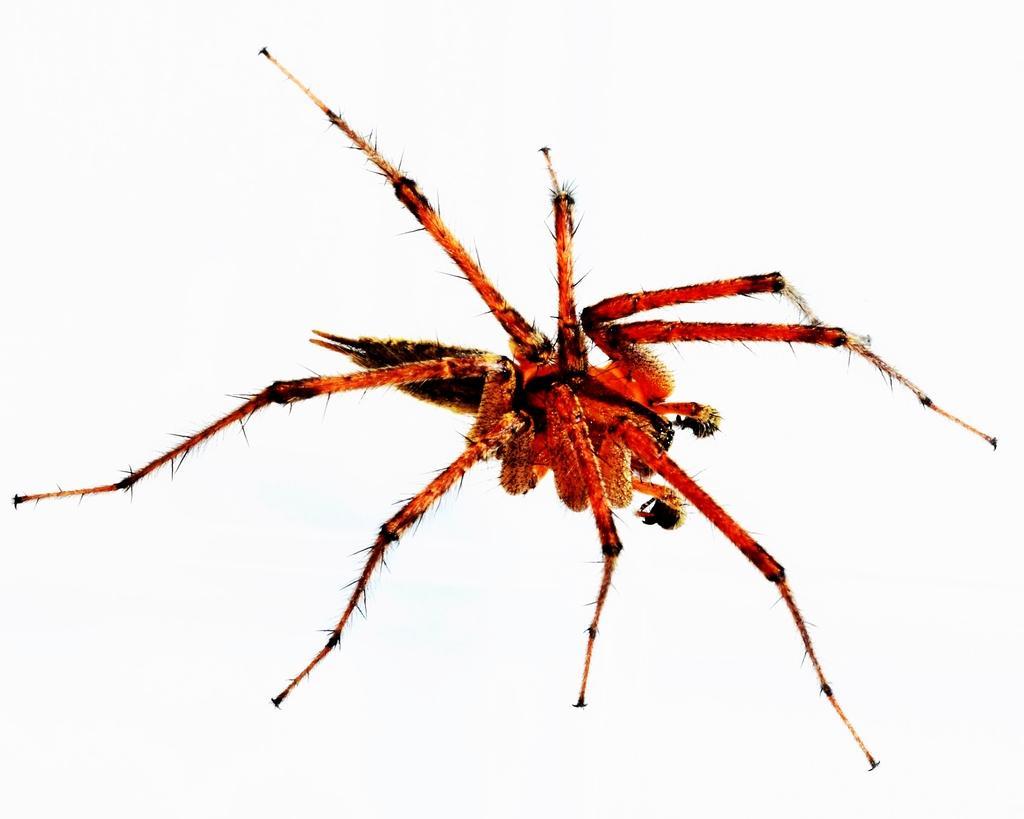Could you give a brief overview of what you see in this image? In this image there is a spider. 